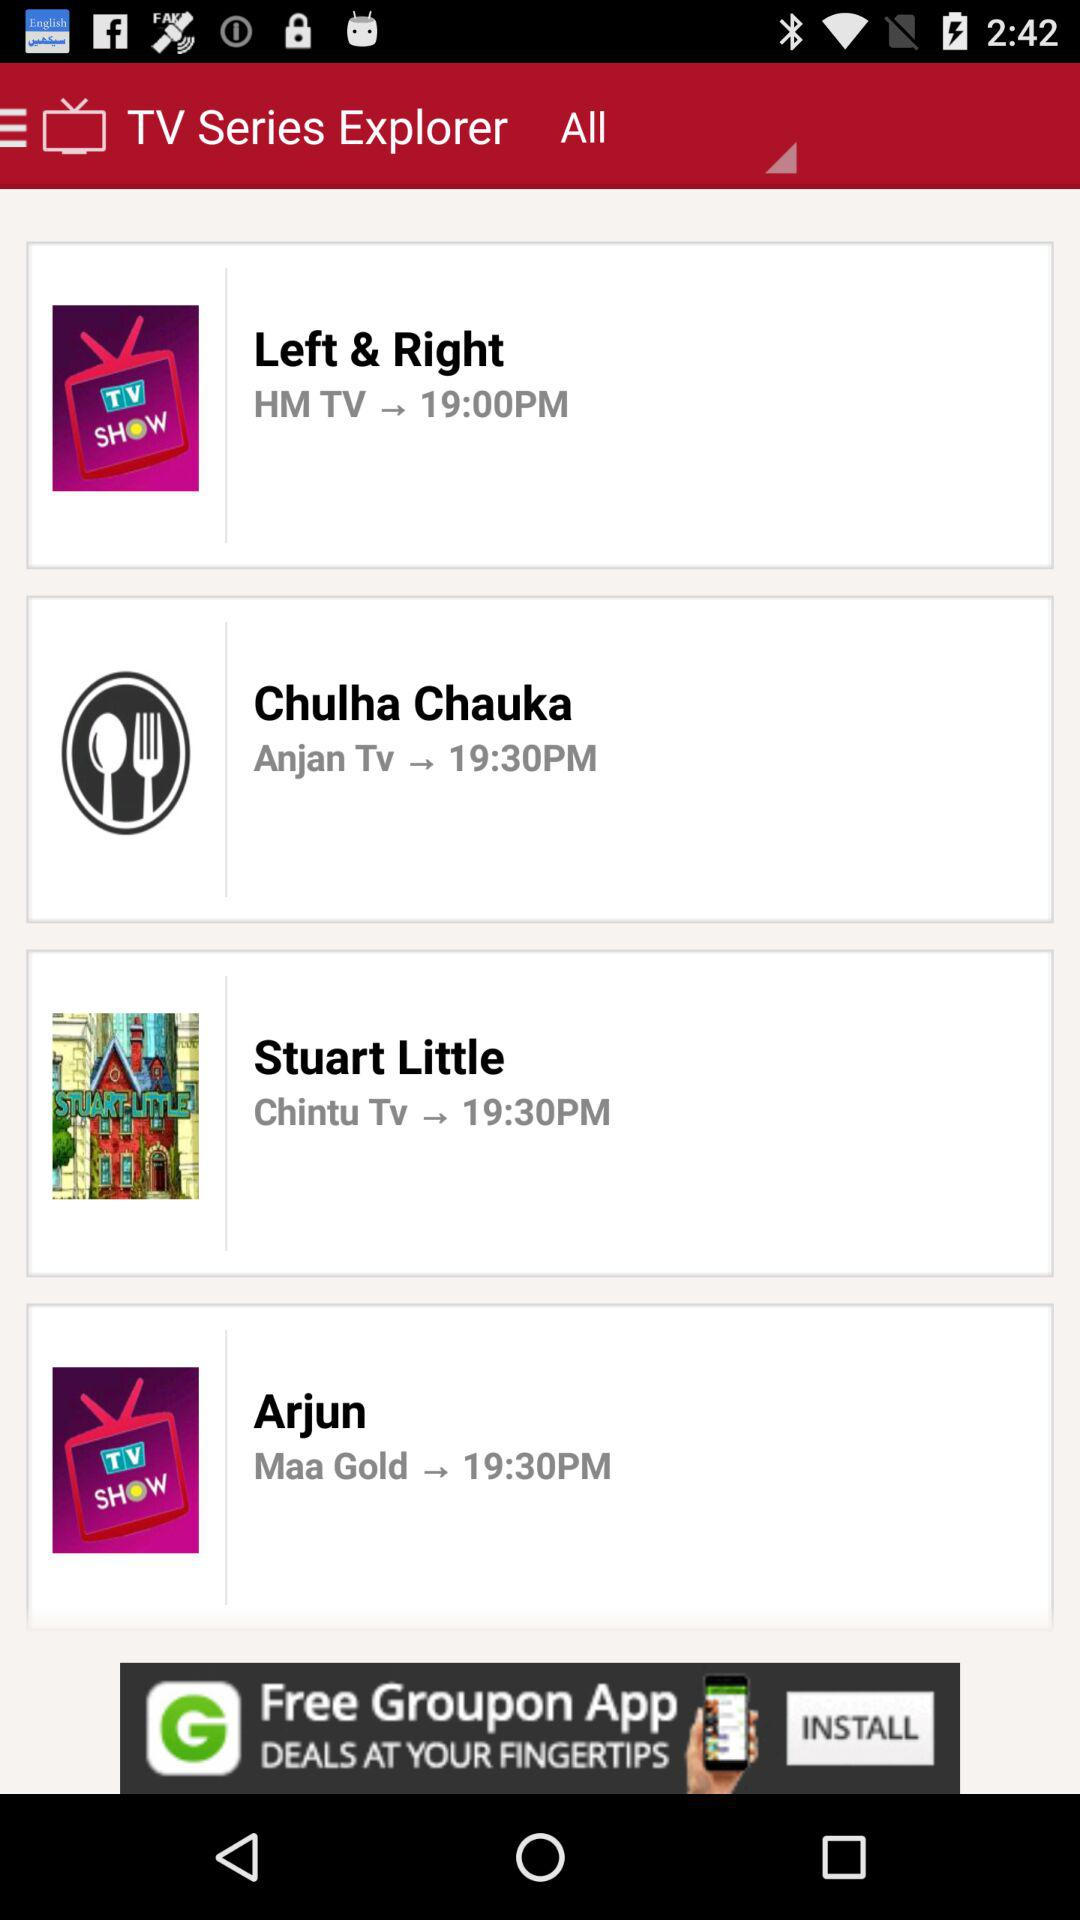What is the time of "Stuart Little"? The time of "Stuart Little" is 19:30. 